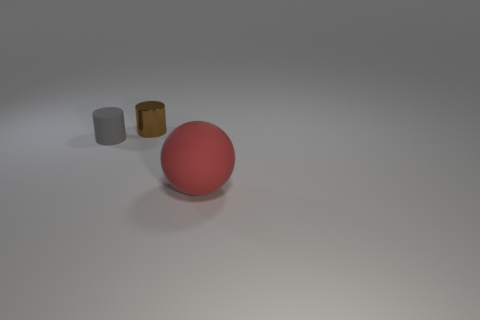Add 1 tiny shiny cylinders. How many objects exist? 4 Subtract 2 cylinders. How many cylinders are left? 0 Subtract all gray cylinders. How many cylinders are left? 1 Subtract all cylinders. How many objects are left? 1 Add 3 red things. How many red things are left? 4 Add 3 small brown metal cylinders. How many small brown metal cylinders exist? 4 Subtract 0 blue cubes. How many objects are left? 3 Subtract all cyan cylinders. Subtract all blue balls. How many cylinders are left? 2 Subtract all green objects. Subtract all small brown things. How many objects are left? 2 